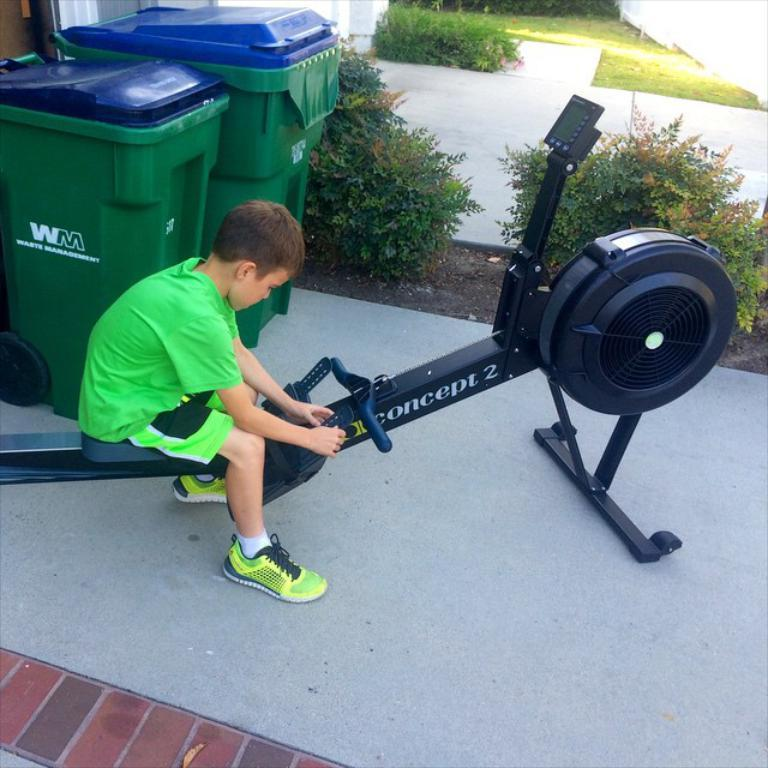Who is the main subject in the image? There is a boy in the image. What is the boy doing in the image? The boy is sitting on a rowing machine. What can be seen in the background of the image? There are bins and plants visible in the background of the image. What type of surface is the boy sitting on? There is grass in the image, which is the surface the boy is sitting on. Can you see a zebra in the image? No, there is no zebra present in the image. 